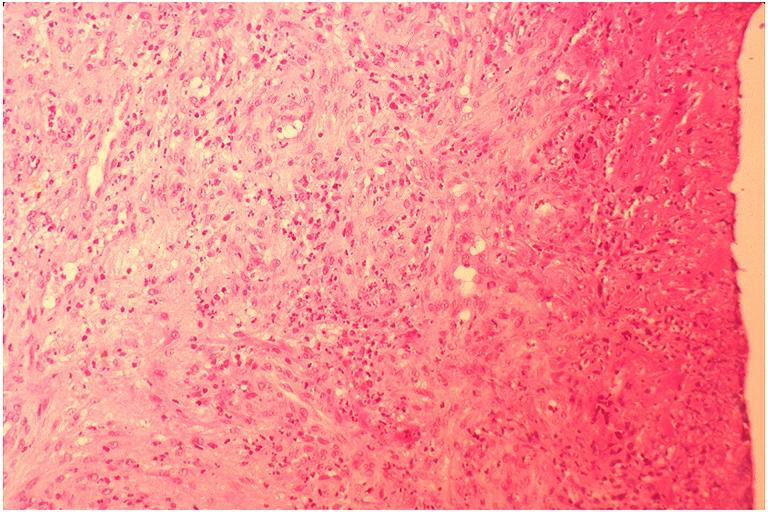what is present?
Answer the question using a single word or phrase. Oral 